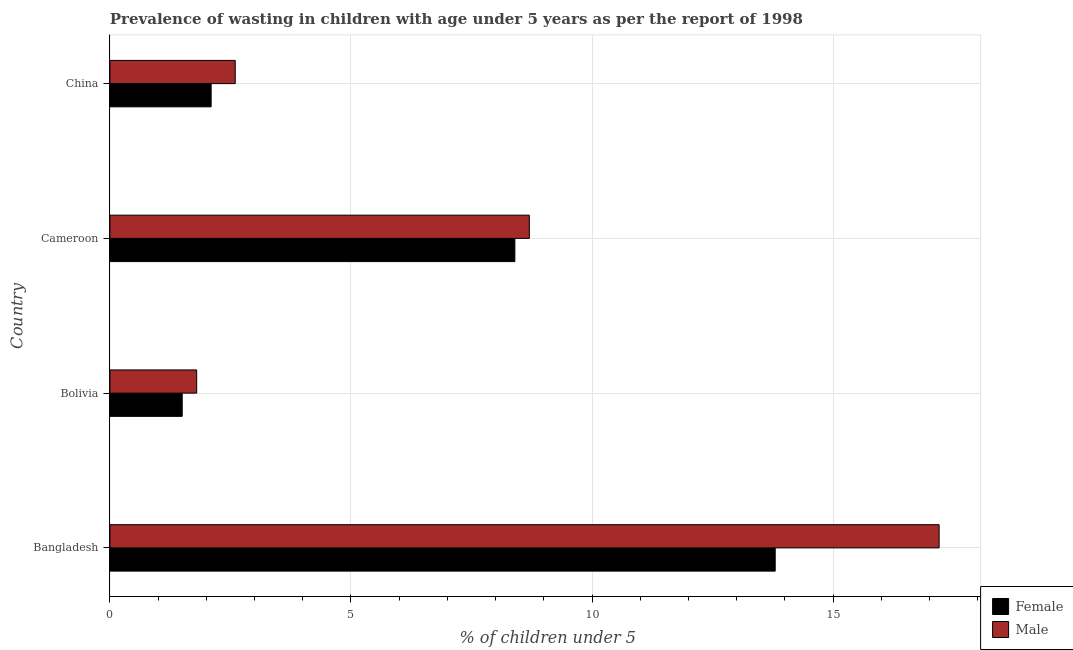How many groups of bars are there?
Make the answer very short. 4. Are the number of bars per tick equal to the number of legend labels?
Give a very brief answer. Yes. How many bars are there on the 1st tick from the top?
Your response must be concise. 2. What is the label of the 1st group of bars from the top?
Make the answer very short. China. In how many cases, is the number of bars for a given country not equal to the number of legend labels?
Your answer should be compact. 0. What is the percentage of undernourished female children in Bolivia?
Make the answer very short. 1.5. Across all countries, what is the maximum percentage of undernourished female children?
Make the answer very short. 13.8. Across all countries, what is the minimum percentage of undernourished female children?
Your answer should be compact. 1.5. In which country was the percentage of undernourished male children maximum?
Provide a succinct answer. Bangladesh. What is the total percentage of undernourished female children in the graph?
Offer a terse response. 25.8. What is the difference between the percentage of undernourished male children in Cameroon and that in China?
Keep it short and to the point. 6.1. What is the difference between the percentage of undernourished male children in Cameroon and the percentage of undernourished female children in China?
Ensure brevity in your answer.  6.6. What is the average percentage of undernourished female children per country?
Ensure brevity in your answer.  6.45. What is the difference between the percentage of undernourished female children and percentage of undernourished male children in Bangladesh?
Offer a terse response. -3.4. In how many countries, is the percentage of undernourished male children greater than 5 %?
Offer a very short reply. 2. What is the ratio of the percentage of undernourished male children in Bolivia to that in Cameroon?
Your response must be concise. 0.21. Is the difference between the percentage of undernourished female children in Bolivia and China greater than the difference between the percentage of undernourished male children in Bolivia and China?
Provide a short and direct response. Yes. What is the difference between the highest and the lowest percentage of undernourished female children?
Make the answer very short. 12.3. What does the 2nd bar from the top in Cameroon represents?
Offer a very short reply. Female. What does the 1st bar from the bottom in Bangladesh represents?
Make the answer very short. Female. What is the difference between two consecutive major ticks on the X-axis?
Ensure brevity in your answer.  5. Where does the legend appear in the graph?
Keep it short and to the point. Bottom right. How many legend labels are there?
Make the answer very short. 2. How are the legend labels stacked?
Give a very brief answer. Vertical. What is the title of the graph?
Ensure brevity in your answer.  Prevalence of wasting in children with age under 5 years as per the report of 1998. What is the label or title of the X-axis?
Make the answer very short.  % of children under 5. What is the  % of children under 5 in Female in Bangladesh?
Your response must be concise. 13.8. What is the  % of children under 5 of Male in Bangladesh?
Your answer should be very brief. 17.2. What is the  % of children under 5 of Female in Bolivia?
Ensure brevity in your answer.  1.5. What is the  % of children under 5 of Male in Bolivia?
Give a very brief answer. 1.8. What is the  % of children under 5 in Female in Cameroon?
Give a very brief answer. 8.4. What is the  % of children under 5 in Male in Cameroon?
Offer a very short reply. 8.7. What is the  % of children under 5 of Female in China?
Provide a short and direct response. 2.1. What is the  % of children under 5 in Male in China?
Provide a short and direct response. 2.6. Across all countries, what is the maximum  % of children under 5 in Female?
Your response must be concise. 13.8. Across all countries, what is the maximum  % of children under 5 of Male?
Your answer should be compact. 17.2. Across all countries, what is the minimum  % of children under 5 in Male?
Make the answer very short. 1.8. What is the total  % of children under 5 of Female in the graph?
Your answer should be compact. 25.8. What is the total  % of children under 5 in Male in the graph?
Offer a terse response. 30.3. What is the difference between the  % of children under 5 in Female in Bangladesh and that in Bolivia?
Keep it short and to the point. 12.3. What is the difference between the  % of children under 5 of Male in Bangladesh and that in Bolivia?
Your response must be concise. 15.4. What is the difference between the  % of children under 5 of Female in Bangladesh and that in Cameroon?
Your response must be concise. 5.4. What is the difference between the  % of children under 5 in Female in Bangladesh and that in China?
Provide a succinct answer. 11.7. What is the difference between the  % of children under 5 of Male in Bangladesh and that in China?
Provide a succinct answer. 14.6. What is the difference between the  % of children under 5 of Female in Bolivia and that in China?
Provide a succinct answer. -0.6. What is the difference between the  % of children under 5 in Male in Bolivia and that in China?
Your answer should be very brief. -0.8. What is the difference between the  % of children under 5 in Female in Cameroon and that in China?
Make the answer very short. 6.3. What is the difference between the  % of children under 5 in Male in Cameroon and that in China?
Keep it short and to the point. 6.1. What is the difference between the  % of children under 5 of Female in Bangladesh and the  % of children under 5 of Male in Cameroon?
Give a very brief answer. 5.1. What is the difference between the  % of children under 5 of Female in Bolivia and the  % of children under 5 of Male in Cameroon?
Ensure brevity in your answer.  -7.2. What is the average  % of children under 5 in Female per country?
Keep it short and to the point. 6.45. What is the average  % of children under 5 in Male per country?
Provide a succinct answer. 7.58. What is the difference between the  % of children under 5 of Female and  % of children under 5 of Male in Bangladesh?
Offer a terse response. -3.4. What is the difference between the  % of children under 5 of Female and  % of children under 5 of Male in Cameroon?
Offer a terse response. -0.3. What is the difference between the  % of children under 5 in Female and  % of children under 5 in Male in China?
Your answer should be compact. -0.5. What is the ratio of the  % of children under 5 in Female in Bangladesh to that in Bolivia?
Your answer should be very brief. 9.2. What is the ratio of the  % of children under 5 in Male in Bangladesh to that in Bolivia?
Provide a short and direct response. 9.56. What is the ratio of the  % of children under 5 in Female in Bangladesh to that in Cameroon?
Give a very brief answer. 1.64. What is the ratio of the  % of children under 5 in Male in Bangladesh to that in Cameroon?
Your answer should be compact. 1.98. What is the ratio of the  % of children under 5 in Female in Bangladesh to that in China?
Your answer should be very brief. 6.57. What is the ratio of the  % of children under 5 of Male in Bangladesh to that in China?
Keep it short and to the point. 6.62. What is the ratio of the  % of children under 5 in Female in Bolivia to that in Cameroon?
Make the answer very short. 0.18. What is the ratio of the  % of children under 5 in Male in Bolivia to that in Cameroon?
Ensure brevity in your answer.  0.21. What is the ratio of the  % of children under 5 of Female in Bolivia to that in China?
Keep it short and to the point. 0.71. What is the ratio of the  % of children under 5 of Male in Bolivia to that in China?
Provide a short and direct response. 0.69. What is the ratio of the  % of children under 5 in Male in Cameroon to that in China?
Your answer should be compact. 3.35. What is the difference between the highest and the second highest  % of children under 5 of Female?
Keep it short and to the point. 5.4. What is the difference between the highest and the lowest  % of children under 5 in Male?
Your response must be concise. 15.4. 